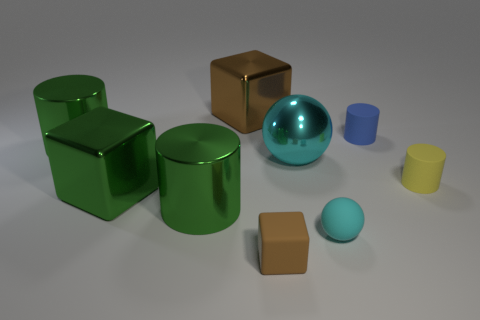Add 1 large cyan metal spheres. How many objects exist? 10 Subtract all cylinders. How many objects are left? 5 Add 7 brown cubes. How many brown cubes are left? 9 Add 8 small gray matte spheres. How many small gray matte spheres exist? 8 Subtract 1 blue cylinders. How many objects are left? 8 Subtract all large metallic cylinders. Subtract all green metal cubes. How many objects are left? 6 